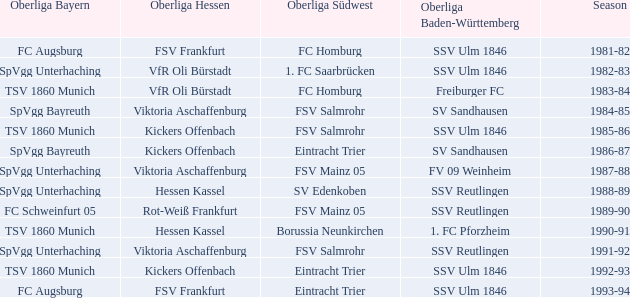Which Oberliga Bayern has a Season of 1981-82? FC Augsburg. 